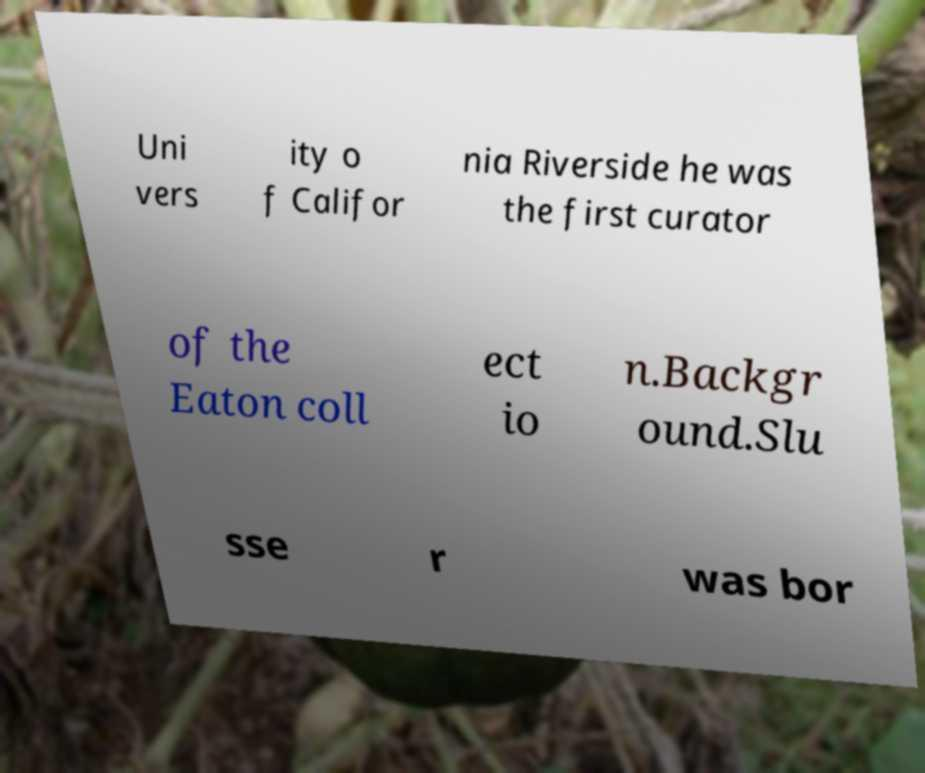Can you accurately transcribe the text from the provided image for me? Uni vers ity o f Califor nia Riverside he was the first curator of the Eaton coll ect io n.Backgr ound.Slu sse r was bor 